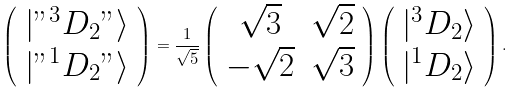<formula> <loc_0><loc_0><loc_500><loc_500>\left ( \begin{array} { c } | " ^ { 3 } D _ { 2 } " \rangle \\ | " ^ { 1 } D _ { 2 } " \rangle \end{array} \right ) = \frac { 1 } { \sqrt { 5 } } \left ( \begin{array} { c c } \sqrt { 3 } & \sqrt { 2 } \\ - \sqrt { 2 } & \sqrt { 3 } \end{array} \right ) \left ( \begin{array} { c } | ^ { 3 } D _ { 2 } \rangle \\ | ^ { 1 } D _ { 2 } \rangle \end{array} \right ) .</formula> 